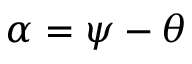Convert formula to latex. <formula><loc_0><loc_0><loc_500><loc_500>\alpha = \psi - \theta</formula> 